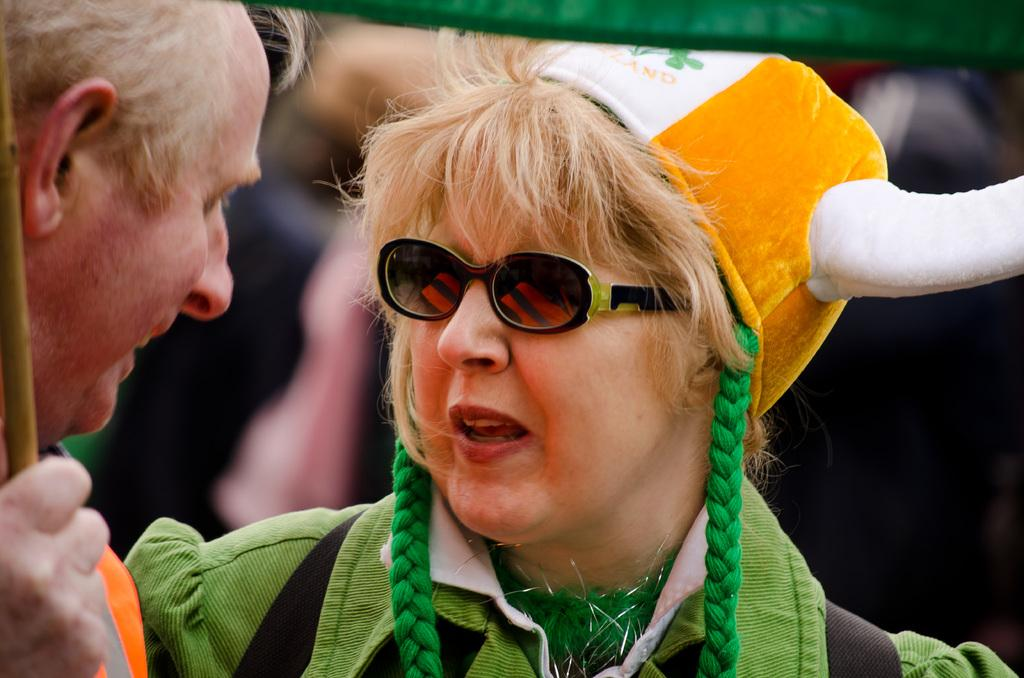Who is the main subject in the center of the image? There is a woman in the center of the image. What is the woman wearing? The woman is wearing a costume. Can you describe the man on the left side of the image? There is a man on the left side of the image. What type of vegetable is the woman holding in the image? There is no vegetable present in the image; the woman is wearing a costume. What direction is the man facing in the image? The provided facts do not mention the direction the man is facing, so it cannot be determined from the image. 